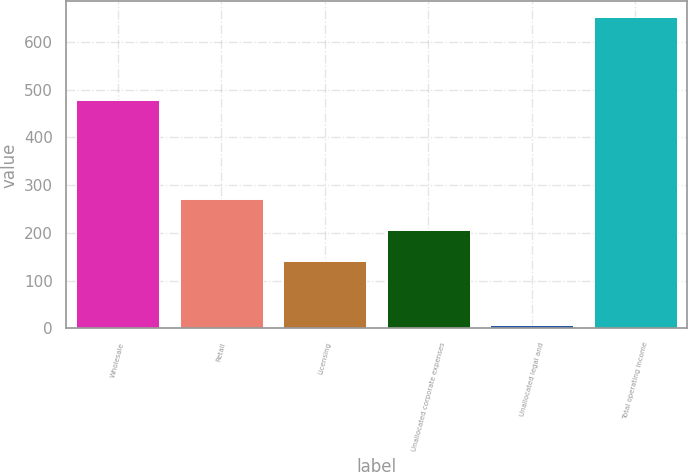Convert chart to OTSL. <chart><loc_0><loc_0><loc_500><loc_500><bar_chart><fcel>Wholesale<fcel>Retail<fcel>Licensing<fcel>Unallocated corporate expenses<fcel>Unallocated legal and<fcel>Total operating income<nl><fcel>477.8<fcel>270.6<fcel>141.6<fcel>206.1<fcel>7.6<fcel>652.6<nl></chart> 